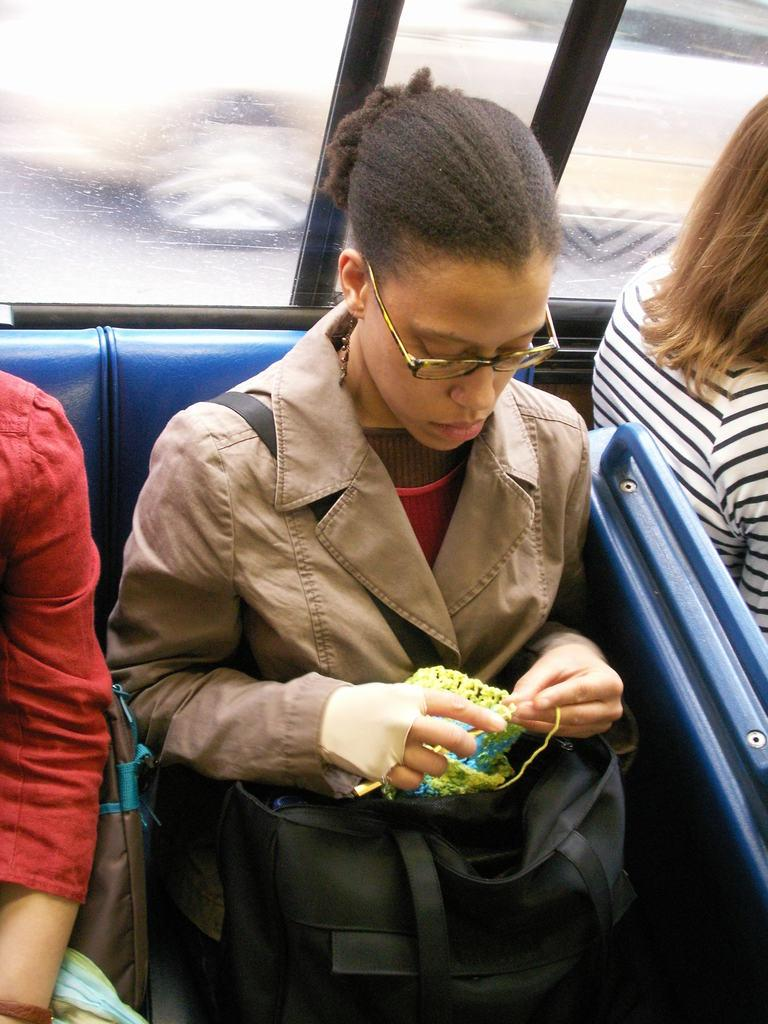What is the main subject of the image? The main subject of the image is a group of people. Can you describe any specific details about the people in the image? One woman in the group is wearing spectacles. What type of drain is visible in the image? There is no drain present in the image; it features a group of people, one of whom is wearing spectacles. How many crackers are being held by the people in the image? There is no mention of crackers in the image, so it is impossible to determine how many are being held. 